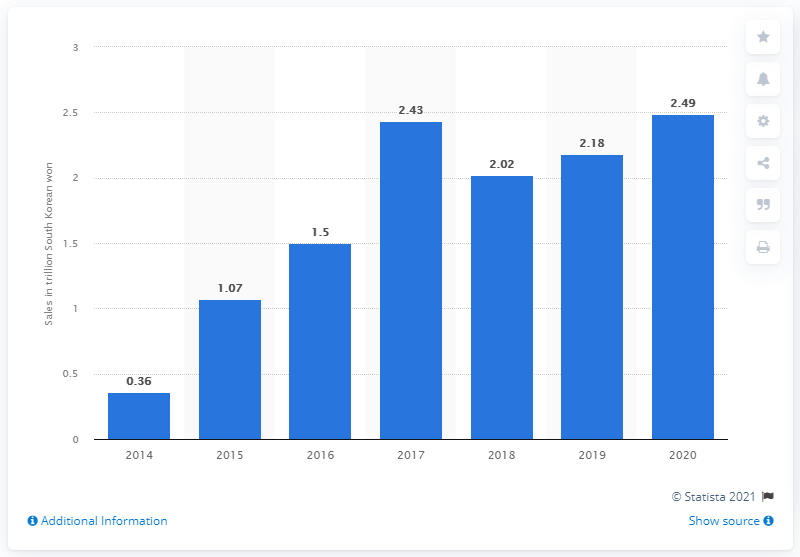Draw attention to some important aspects in this diagram. In 2020, Netmarble's operating revenue reached 2.49 trillion South Korean won. In 2020, Netmarble's operating revenue in South Korea was 2.49 trillion won. 